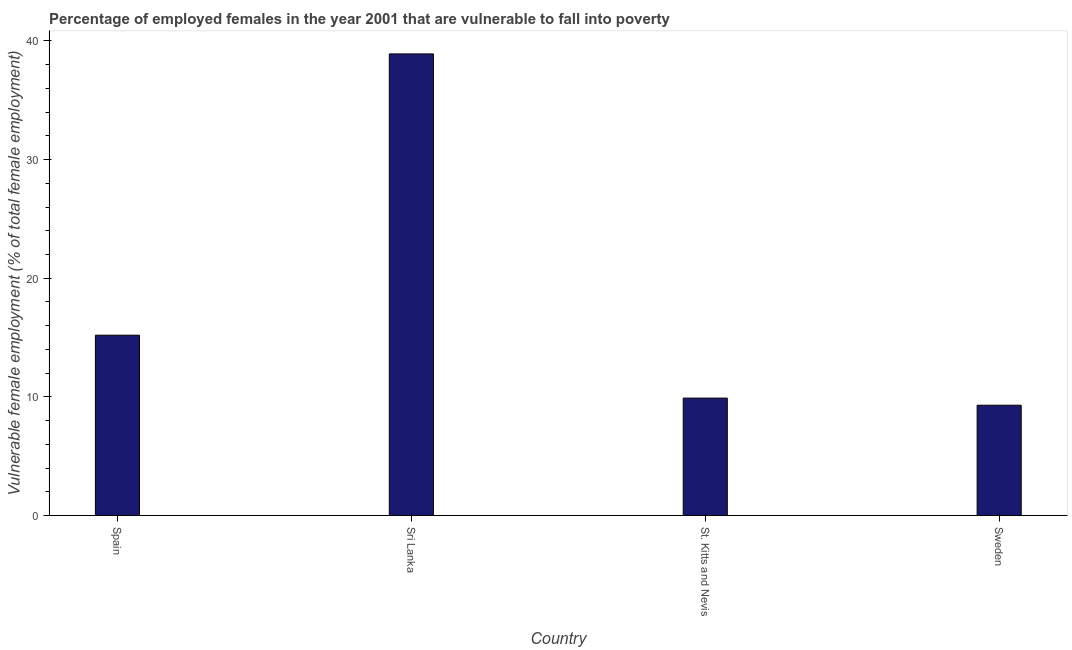Does the graph contain grids?
Offer a very short reply. No. What is the title of the graph?
Provide a short and direct response. Percentage of employed females in the year 2001 that are vulnerable to fall into poverty. What is the label or title of the Y-axis?
Offer a very short reply. Vulnerable female employment (% of total female employment). What is the percentage of employed females who are vulnerable to fall into poverty in Spain?
Your response must be concise. 15.2. Across all countries, what is the maximum percentage of employed females who are vulnerable to fall into poverty?
Make the answer very short. 38.9. Across all countries, what is the minimum percentage of employed females who are vulnerable to fall into poverty?
Give a very brief answer. 9.3. In which country was the percentage of employed females who are vulnerable to fall into poverty maximum?
Your answer should be very brief. Sri Lanka. What is the sum of the percentage of employed females who are vulnerable to fall into poverty?
Give a very brief answer. 73.3. What is the difference between the percentage of employed females who are vulnerable to fall into poverty in Spain and St. Kitts and Nevis?
Provide a succinct answer. 5.3. What is the average percentage of employed females who are vulnerable to fall into poverty per country?
Your response must be concise. 18.32. What is the median percentage of employed females who are vulnerable to fall into poverty?
Make the answer very short. 12.55. What is the ratio of the percentage of employed females who are vulnerable to fall into poverty in St. Kitts and Nevis to that in Sweden?
Offer a very short reply. 1.06. Is the difference between the percentage of employed females who are vulnerable to fall into poverty in St. Kitts and Nevis and Sweden greater than the difference between any two countries?
Your answer should be compact. No. What is the difference between the highest and the second highest percentage of employed females who are vulnerable to fall into poverty?
Your answer should be compact. 23.7. Is the sum of the percentage of employed females who are vulnerable to fall into poverty in Sri Lanka and St. Kitts and Nevis greater than the maximum percentage of employed females who are vulnerable to fall into poverty across all countries?
Give a very brief answer. Yes. What is the difference between the highest and the lowest percentage of employed females who are vulnerable to fall into poverty?
Give a very brief answer. 29.6. How many bars are there?
Provide a short and direct response. 4. Are all the bars in the graph horizontal?
Give a very brief answer. No. How many countries are there in the graph?
Ensure brevity in your answer.  4. What is the difference between two consecutive major ticks on the Y-axis?
Make the answer very short. 10. Are the values on the major ticks of Y-axis written in scientific E-notation?
Provide a succinct answer. No. What is the Vulnerable female employment (% of total female employment) in Spain?
Offer a terse response. 15.2. What is the Vulnerable female employment (% of total female employment) in Sri Lanka?
Offer a terse response. 38.9. What is the Vulnerable female employment (% of total female employment) in St. Kitts and Nevis?
Offer a very short reply. 9.9. What is the Vulnerable female employment (% of total female employment) of Sweden?
Give a very brief answer. 9.3. What is the difference between the Vulnerable female employment (% of total female employment) in Spain and Sri Lanka?
Offer a terse response. -23.7. What is the difference between the Vulnerable female employment (% of total female employment) in Spain and St. Kitts and Nevis?
Offer a very short reply. 5.3. What is the difference between the Vulnerable female employment (% of total female employment) in Sri Lanka and St. Kitts and Nevis?
Offer a terse response. 29. What is the difference between the Vulnerable female employment (% of total female employment) in Sri Lanka and Sweden?
Your answer should be very brief. 29.6. What is the ratio of the Vulnerable female employment (% of total female employment) in Spain to that in Sri Lanka?
Keep it short and to the point. 0.39. What is the ratio of the Vulnerable female employment (% of total female employment) in Spain to that in St. Kitts and Nevis?
Ensure brevity in your answer.  1.53. What is the ratio of the Vulnerable female employment (% of total female employment) in Spain to that in Sweden?
Offer a very short reply. 1.63. What is the ratio of the Vulnerable female employment (% of total female employment) in Sri Lanka to that in St. Kitts and Nevis?
Give a very brief answer. 3.93. What is the ratio of the Vulnerable female employment (% of total female employment) in Sri Lanka to that in Sweden?
Your answer should be compact. 4.18. What is the ratio of the Vulnerable female employment (% of total female employment) in St. Kitts and Nevis to that in Sweden?
Keep it short and to the point. 1.06. 